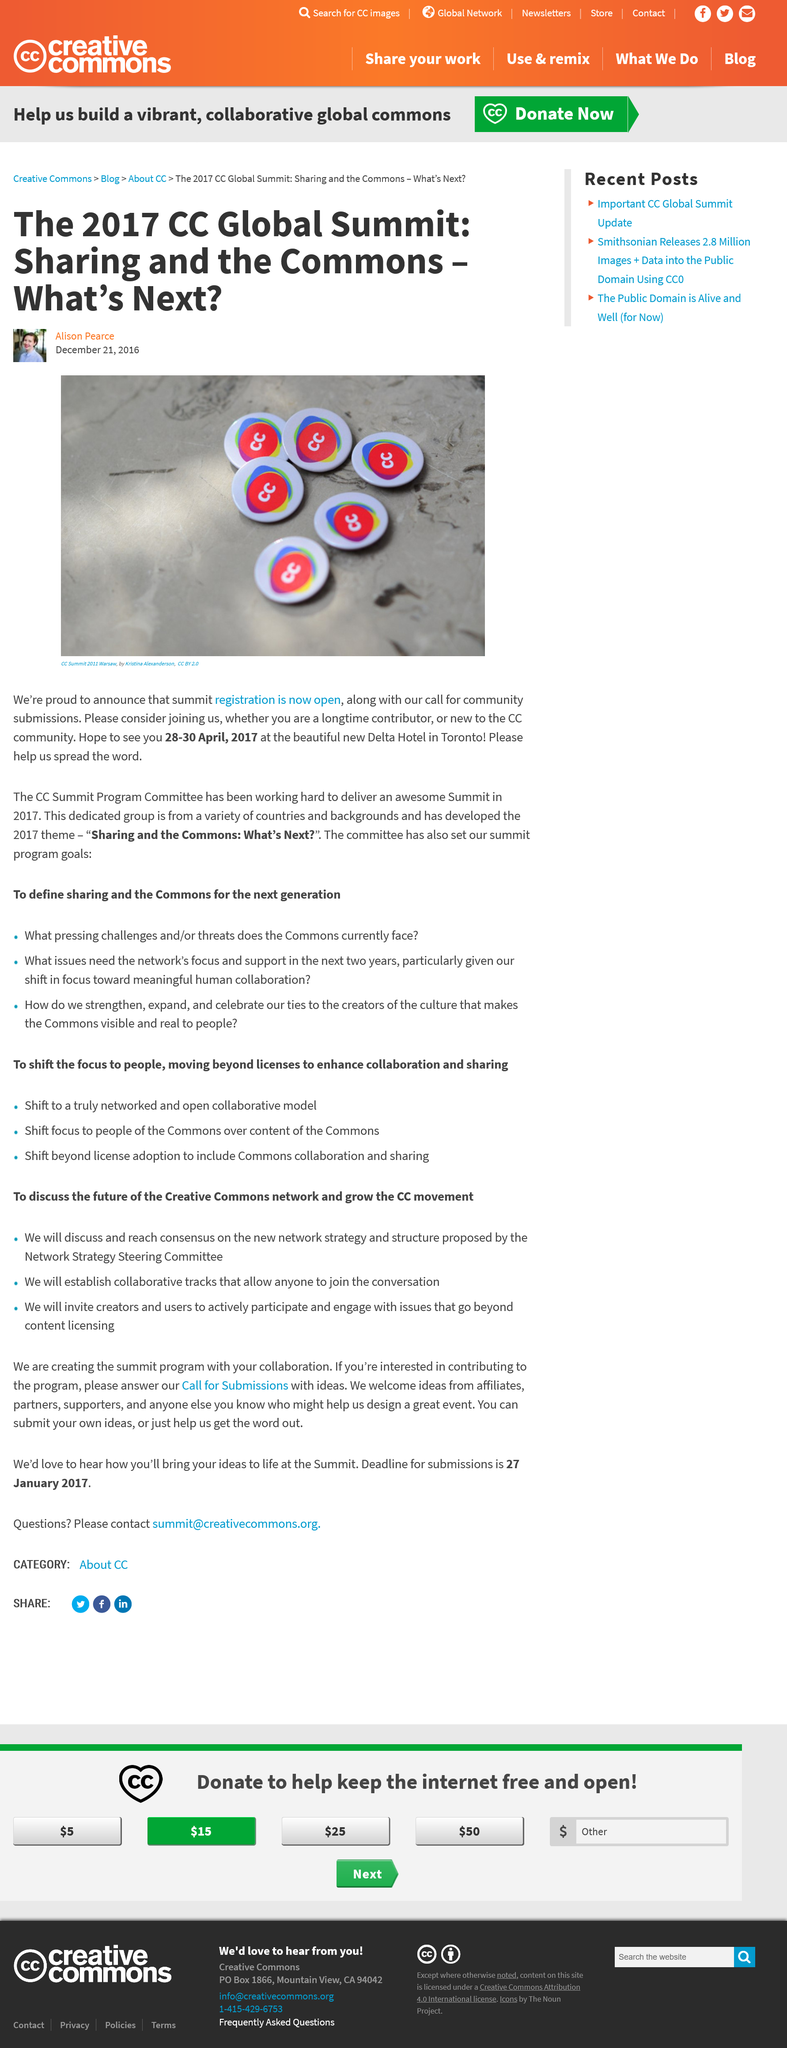Mention a couple of crucial points in this snapshot. The article was published on December 21, 2016. The photograph used in the article was sourced by Kristina Alexanderson. The author intends to be present at the Delta Hotel in Toronto during the period of 28-30 April, 2017. 